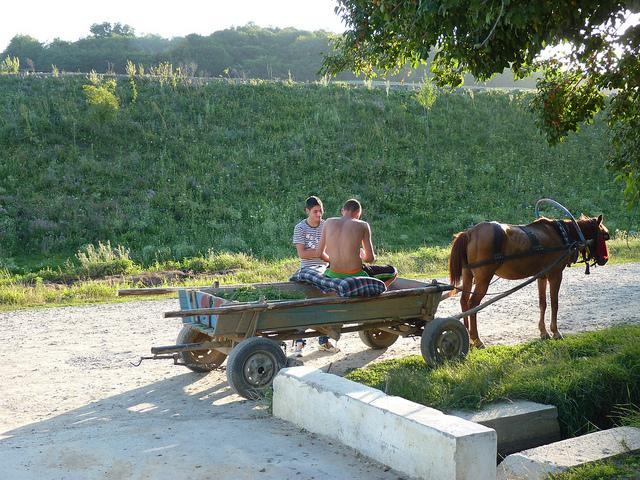How many horses are present?
Give a very brief answer. 1. Does everyone have a shirt on?
Quick response, please. No. Is the grass green?
Give a very brief answer. Yes. 